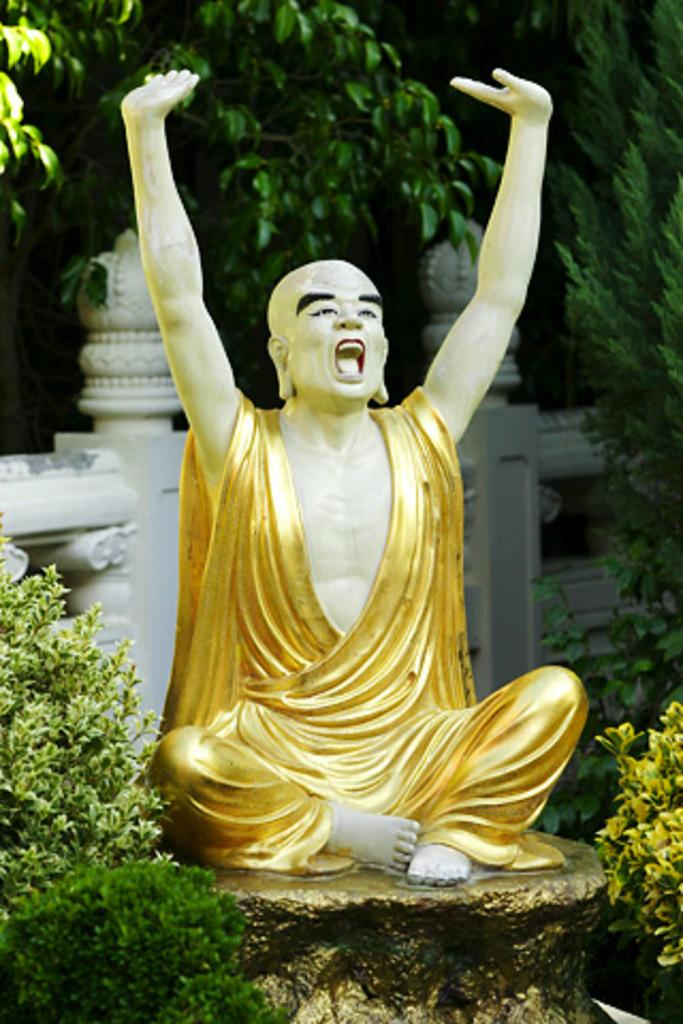What is the main subject on the platform in the image? There is a statue of a person on a platform in the image. What type of vegetation is present on the platform? There are plants on the sides of the platform. What can be seen in the background of the image? There is a wall and trees in the background. What type of pump is used to water the plants in the image? There is no pump present in the image; the plants are not being watered. What type of fiction book is the statue reading in the image? The statue is not reading a book in the image, so it is not possible to determine the type of fiction book. 